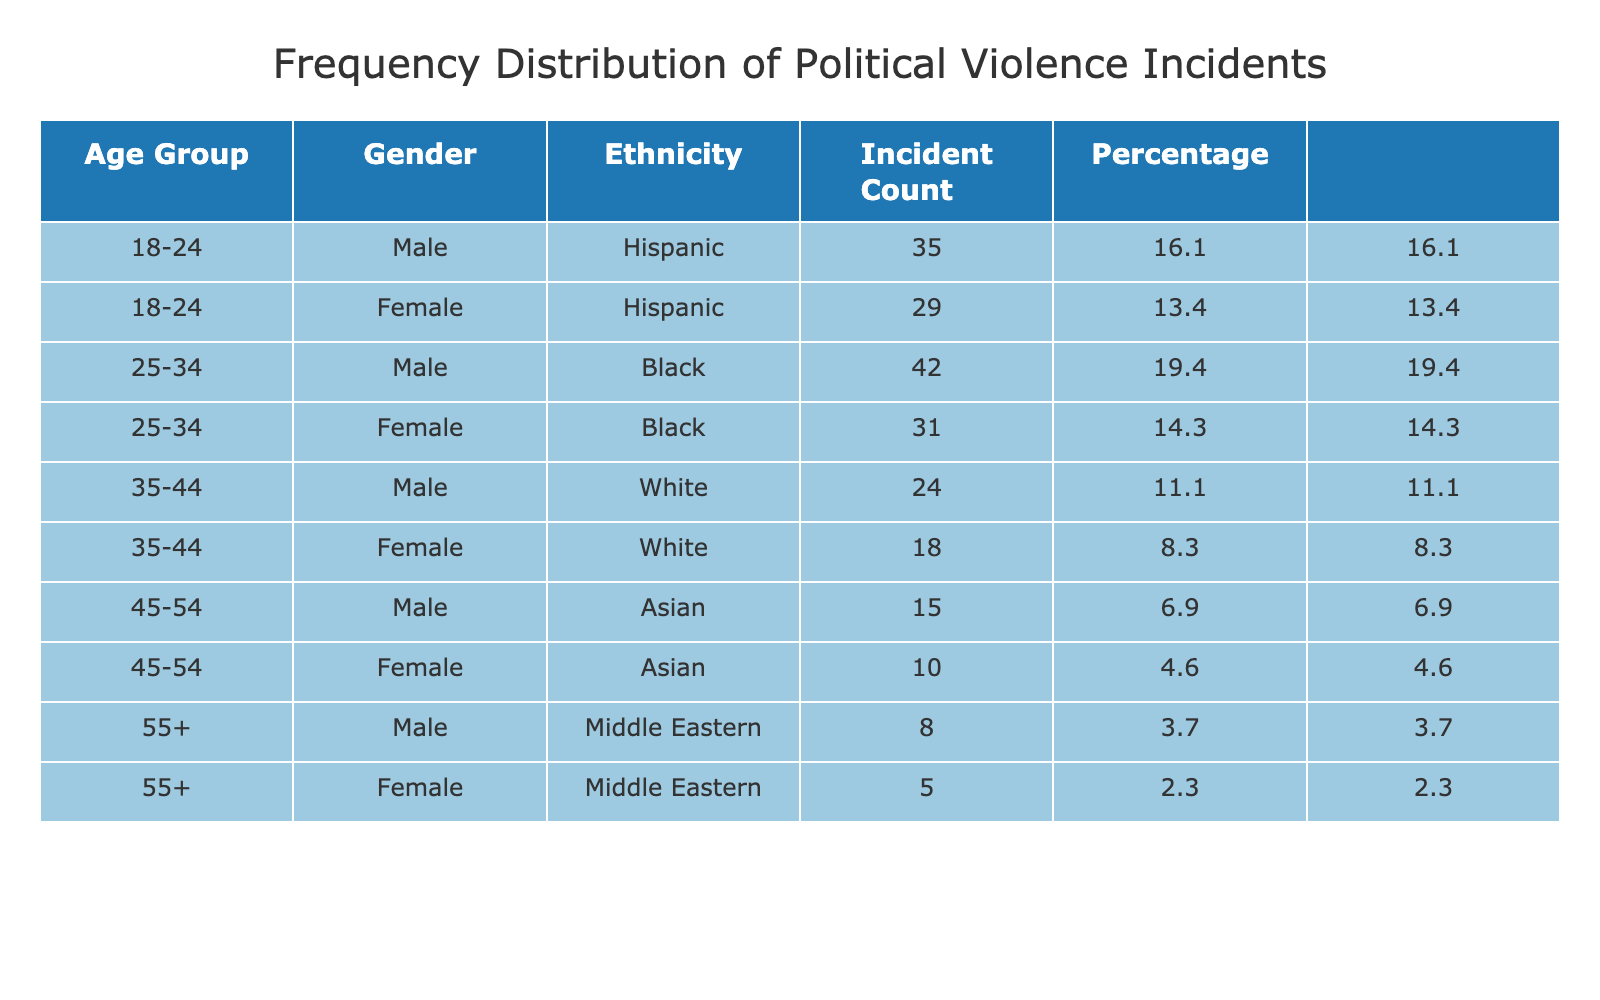What is the incident count for female victims aged 25-34? From the table, we see the row for the age group 25-34 and the gender female lists an incident count of 31.
Answer: 31 What is the percentage of incidents involving male victims compared to the total? To find this, we first identify all male incident counts: 35 (18-24) + 42 (25-34) + 24 (35-44) + 15 (45-54) + 8 (55+) = 124. The total incident count is 307. The percentage is (124 / 307) * 100 = 40.4%.
Answer: 40.4% Which gender has the highest incident count in the 18-24 age group? Looking at the table, the 18-24 age group has 35 incidents for males and 29 for females. Therefore, males have the highest incident count.
Answer: Male What is the total incident count for Asian victims? In the table, for the age group 45-54, Asian males have 15 incidents and Asian females have 10 incidents. Adding these gives 15 + 10 = 25.
Answer: 25 Is the incident count for female victims higher in the 25-34 age group or the 35-44 age group? Female victims aged 25-34 have an incident count of 31, whereas those aged 35-44 have 18. Since 31 > 18, the count for the 25-34 group is higher.
Answer: Yes What age group has the least total incidents, and what is that count? We can find this by summing the incident counts for each age group: 35 + 29 = 64 (18-24), 42 + 31 = 73 (25-34), 24 + 18 = 42 (35-44), 15 + 10 = 25 (45-54), and 8 + 5 = 13 (55+). The least is in the 55+ age group with 13 incidents.
Answer: 55+, 13 What is the combined percentage share of incidents for Hispanic victims across all age groups? The tally for Hispanic incidents is 35 (males) and 29 (females) in the 18-24 age group only. This totals to 64 incidents. The percentage is (64 / 307) * 100 = 20.8%.
Answer: 20.8% Is it true that White females have a higher incident count than Middle Eastern males? From the data, White females have 18 incidents and Middle Eastern males have 8. Since 18 > 8, it is true that White females have a higher count.
Answer: Yes What is the incident count difference between male and female victims for the age group 45-54? Male victims in the 45-54 age group have 15 incidents while female victims have 10. The difference is 15 - 10 = 5.
Answer: 5 